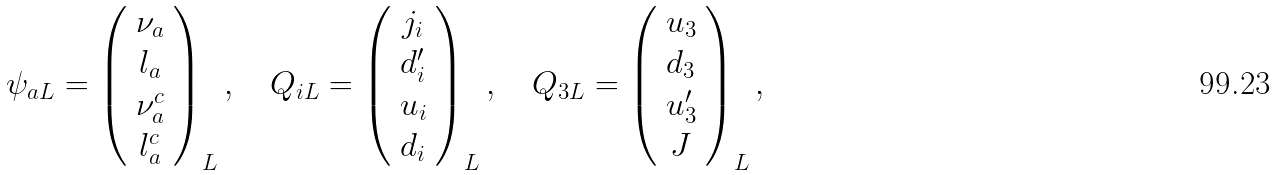Convert formula to latex. <formula><loc_0><loc_0><loc_500><loc_500>\psi _ { a L } = \left ( \begin{array} { c } \nu _ { a } \\ l _ { a } \\ \nu ^ { c } _ { a } \\ l ^ { c } _ { a } \end{array} \right ) _ { L } , \quad Q _ { i L } = \left ( \begin{array} { c } j _ { i } \\ d ^ { \prime } _ { i } \\ u _ { i } \\ d _ { i } \end{array} \right ) _ { L } , \quad Q _ { 3 L } = \left ( \begin{array} { c } u _ { 3 } \\ d _ { 3 } \\ u ^ { \prime } _ { 3 } \\ J \end{array} \right ) _ { L } ,</formula> 